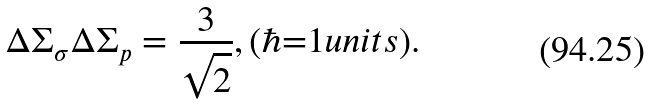Convert formula to latex. <formula><loc_0><loc_0><loc_500><loc_500>\Delta \Sigma _ { \sigma } \Delta \Sigma _ { p } = \frac { 3 } { \sqrt { 2 } } , ( \hbar { = } 1 u n i t s ) .</formula> 